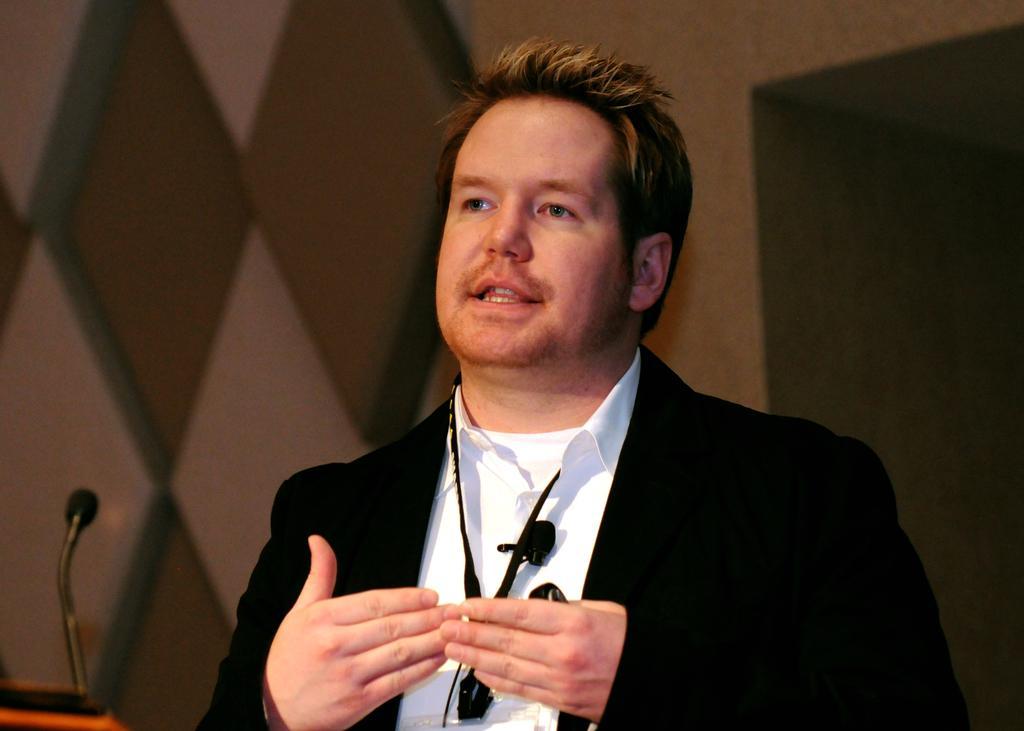Can you describe this image briefly? In this picture we can see a person here, he wore a blazer, in the background there is a wall, we can see a microphone here. 